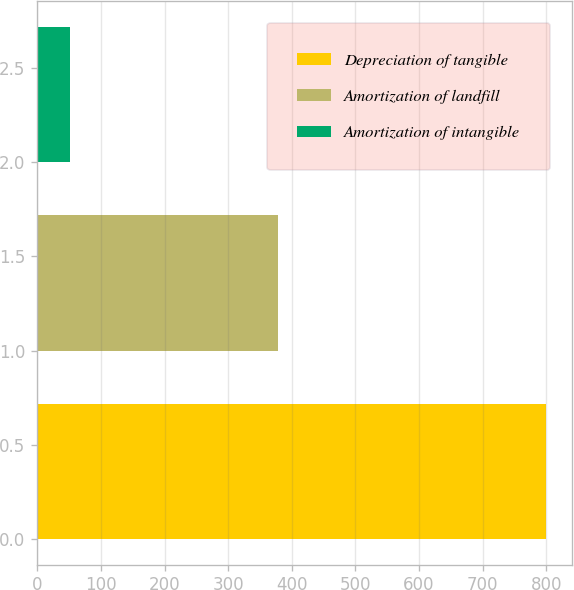<chart> <loc_0><loc_0><loc_500><loc_500><bar_chart><fcel>Depreciation of tangible<fcel>Amortization of landfill<fcel>Amortization of intangible<nl><fcel>800<fcel>378<fcel>51<nl></chart> 